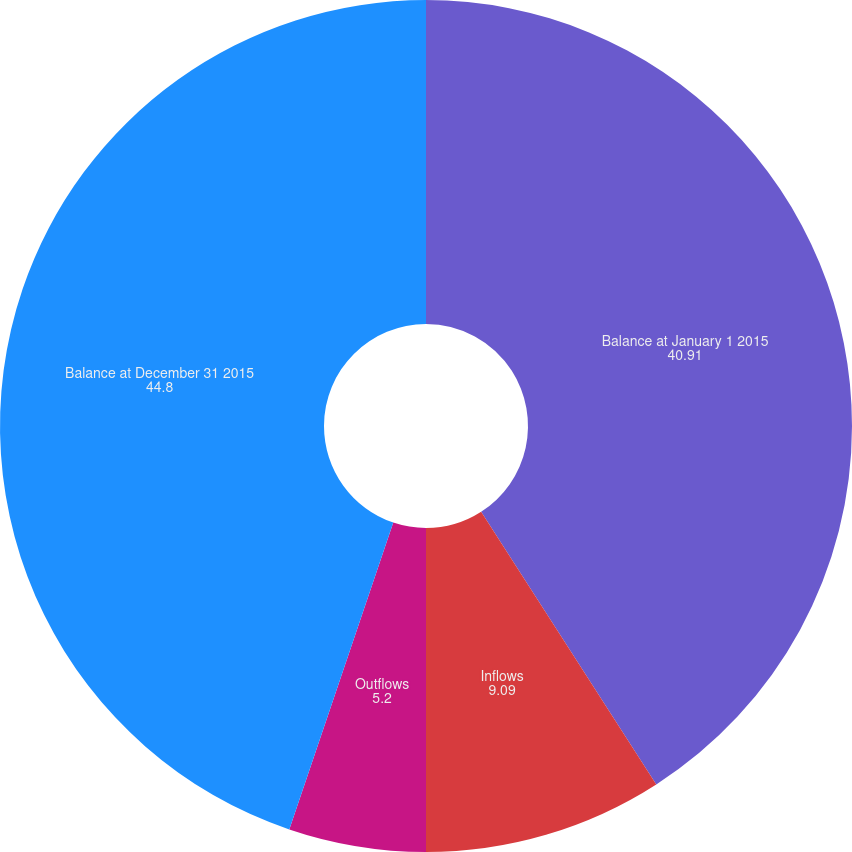Convert chart to OTSL. <chart><loc_0><loc_0><loc_500><loc_500><pie_chart><fcel>Balance at January 1 2015<fcel>Inflows<fcel>Outflows<fcel>Balance at December 31 2015<nl><fcel>40.91%<fcel>9.09%<fcel>5.2%<fcel>44.8%<nl></chart> 